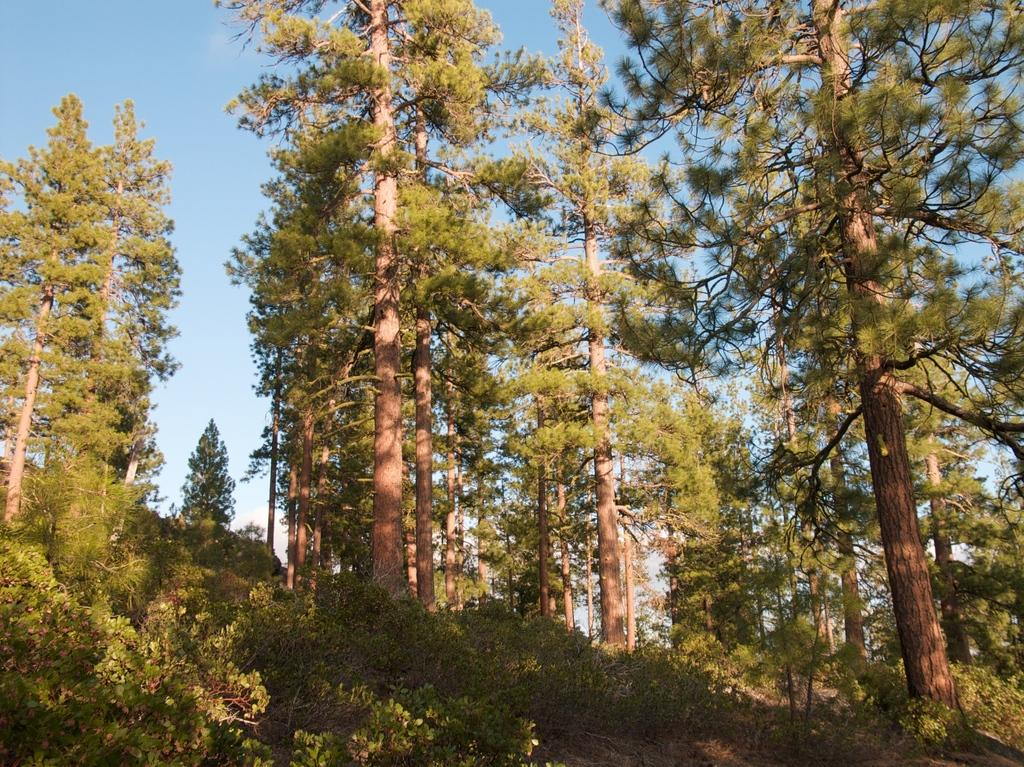What type of natural landform can be seen in the image? There are hills in the image. What type of vegetation is present in the image? There are trees in the image. What is visible in the background of the image? The sky is visible in the background of the image. What can be seen in the sky in the background of the image? There are clouds in the sky in the background of the image. What type of flower is growing on the hills in the image? There is no flower present in the image; it features hills and trees. What type of acoustics can be heard in the image? There is no sound or acoustics present in the image, as it is a still image. 